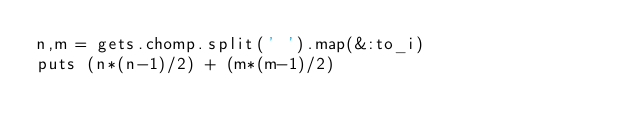Convert code to text. <code><loc_0><loc_0><loc_500><loc_500><_Ruby_>n,m = gets.chomp.split(' ').map(&:to_i)
puts (n*(n-1)/2) + (m*(m-1)/2)</code> 